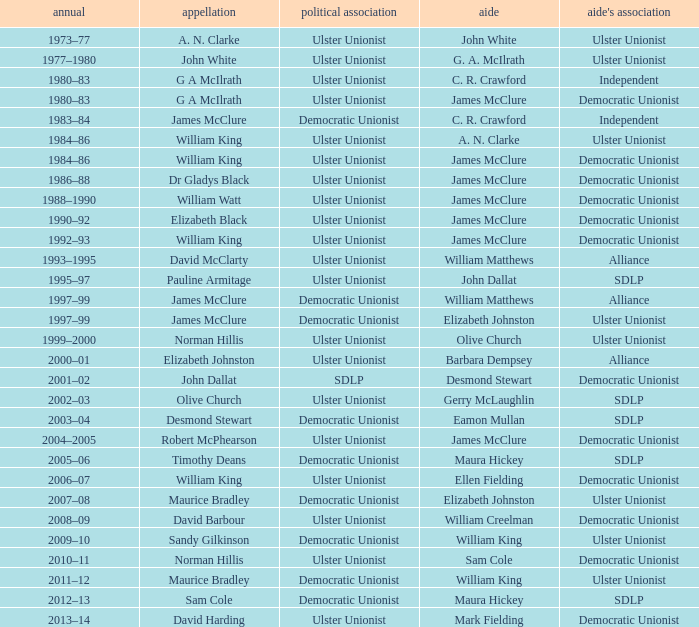What is the Political affiliation of deputy john dallat? Ulster Unionist. 